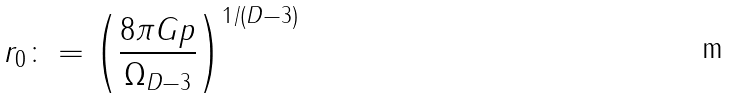<formula> <loc_0><loc_0><loc_500><loc_500>r _ { 0 } \colon = \left ( \frac { 8 \pi G p } { \Omega _ { D - 3 } } \right ) ^ { 1 / ( D - 3 ) }</formula> 